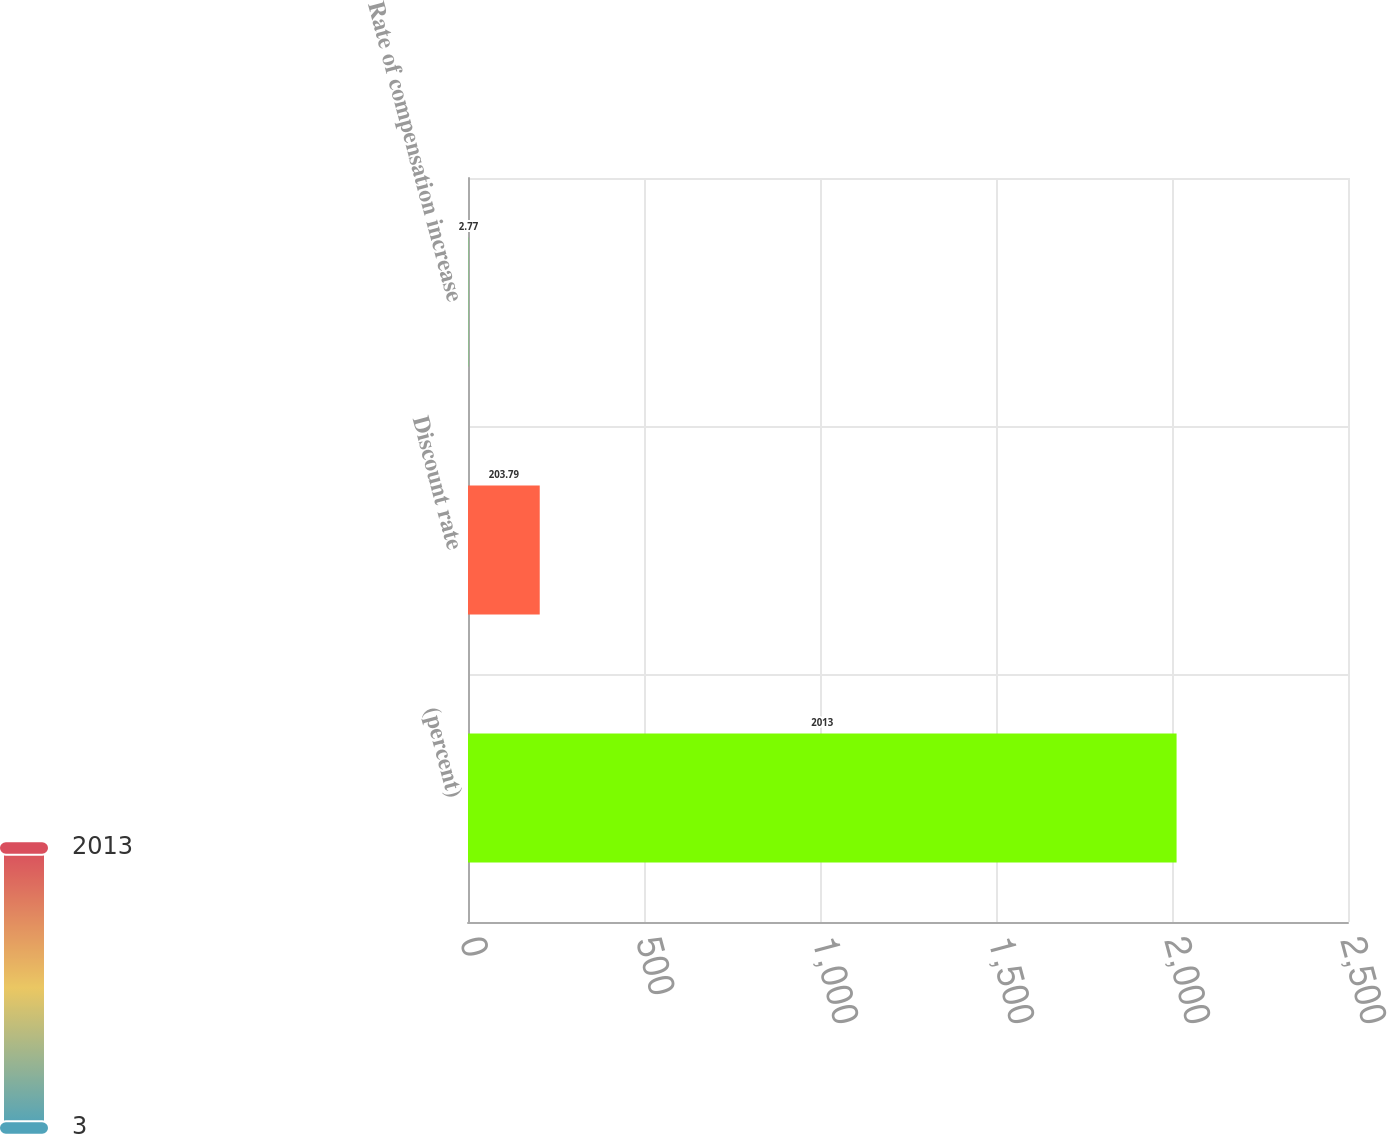Convert chart to OTSL. <chart><loc_0><loc_0><loc_500><loc_500><bar_chart><fcel>(percent)<fcel>Discount rate<fcel>Rate of compensation increase<nl><fcel>2013<fcel>203.79<fcel>2.77<nl></chart> 